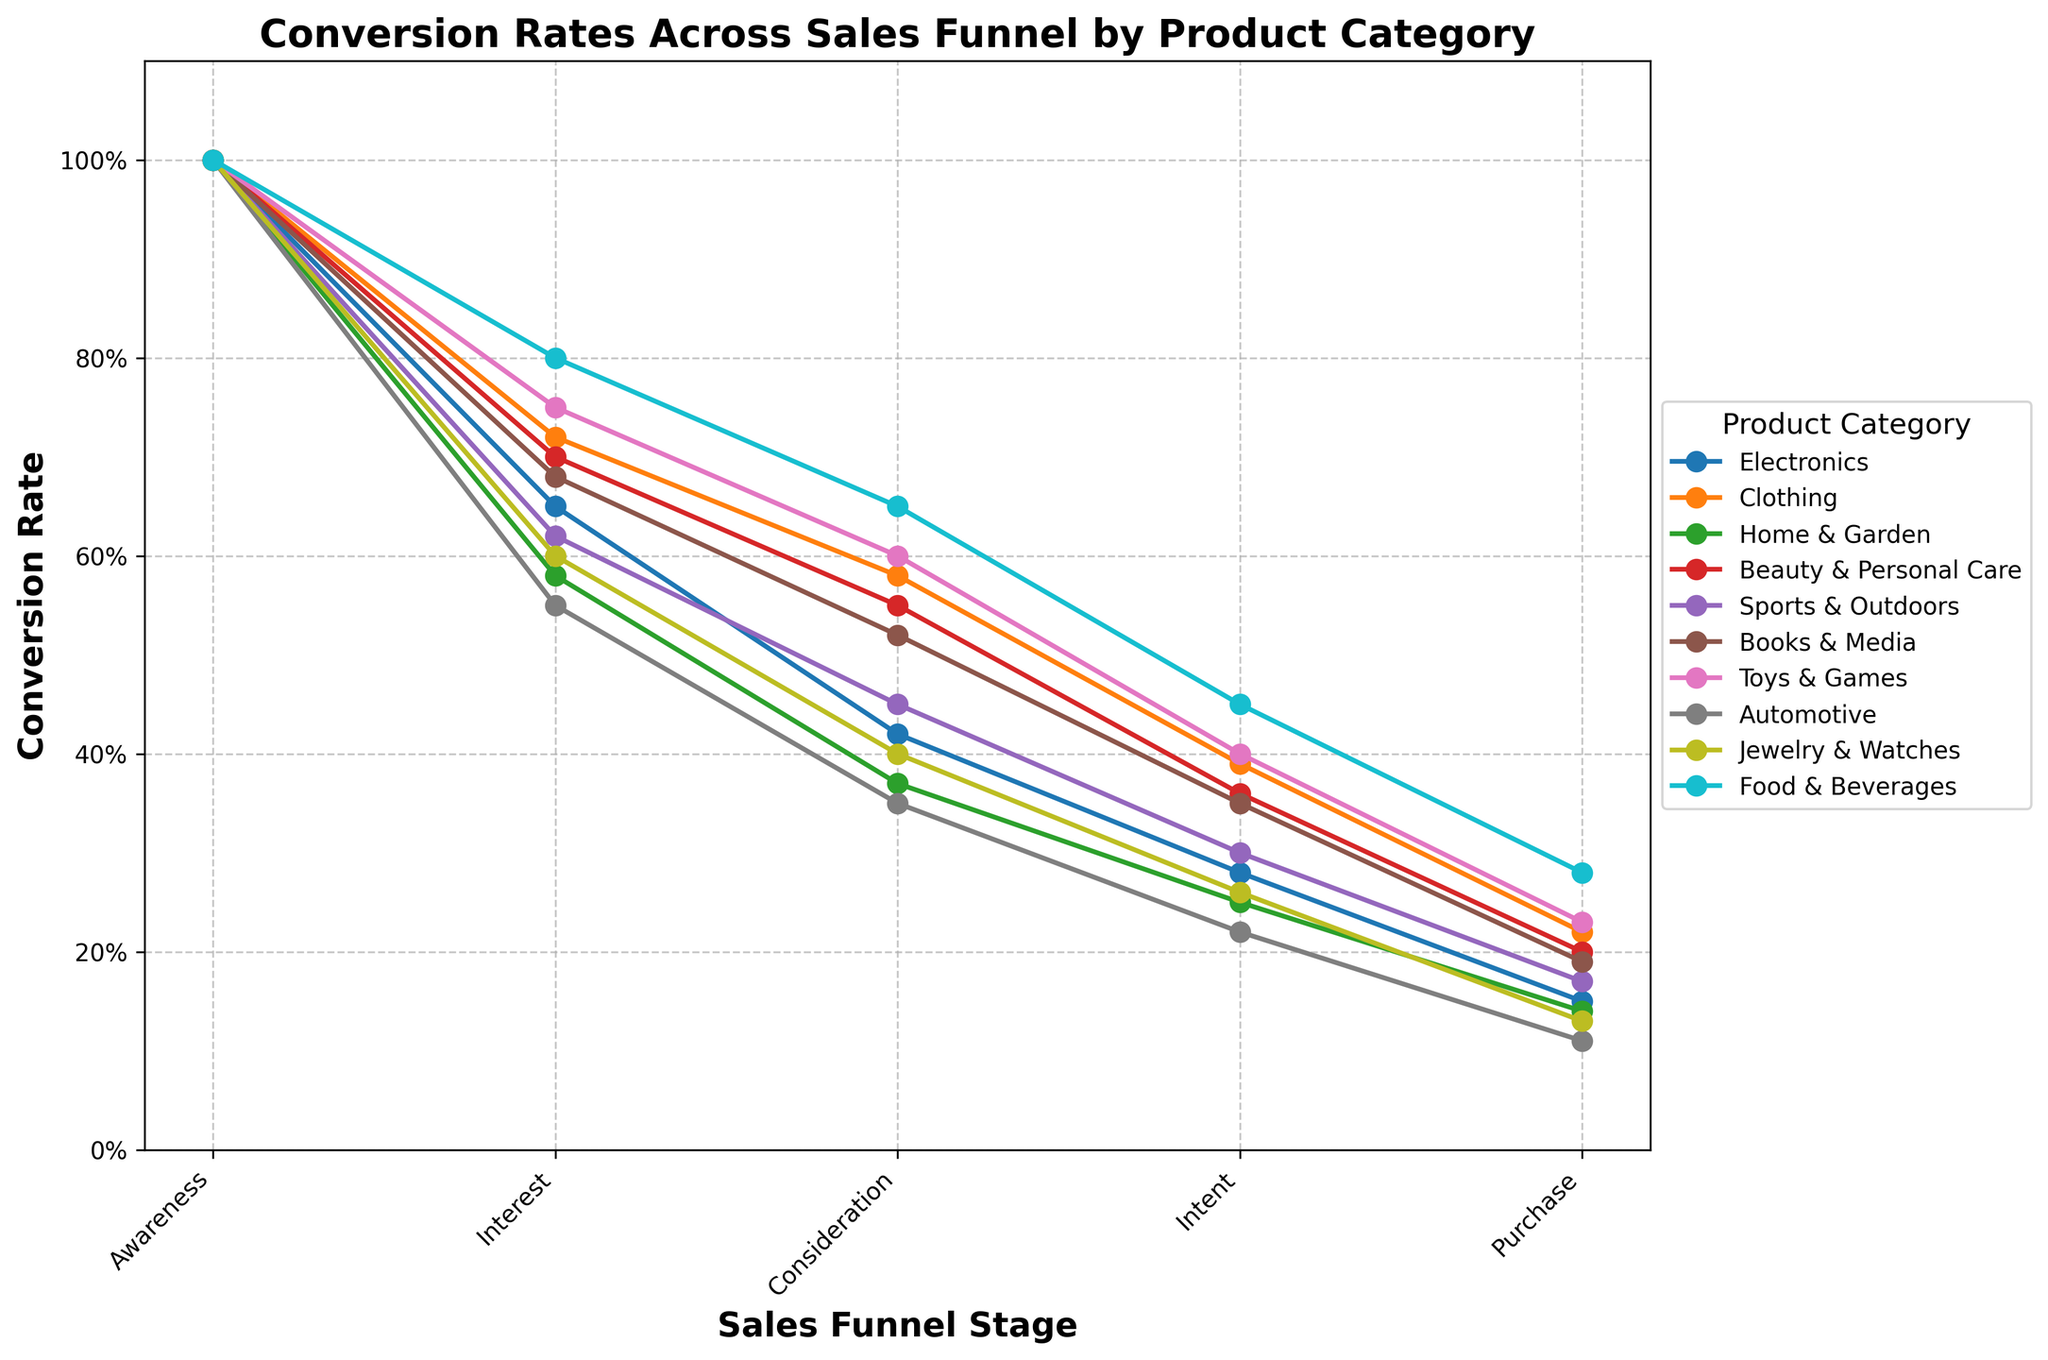What product category has the highest conversion rate at the "Interest" stage? To determine the product category with the highest conversion rate at the "Interest" stage, look at the values for all categories in this stage. The "Food & Beverages" category has an interest conversion rate of 80%, which is the highest among all categories.
Answer: Food & Beverages Which product category shows the steepest drop in conversion rate from "Consideration" to "Intent"? To find this, calculate the difference between the conversion rates of "Consideration" and "Intent" stages for each category. The "Automotive" category falls from 35% in "Consideration" to 22% in "Intent", a drop of 13%, which is the steepest among all categories.
Answer: Automotive Which two product categories have the closest conversion rates at the "Purchase" stage? Compare the conversion rates at the "Purchase" stage for all categories. "Home & Garden" and "Jewelry & Watches" both have close values of 14% and 13%, respectively, which are the closest pair.
Answer: Home & Garden and Jewelry & Watches What is the average conversion rate from "Awareness" to "Purchase" for the "Beauty & Personal Care" category? First, note the conversion rates for "Beauty & Personal Care" are 100%, 70%, 55%, 36%, and 20%. Convert these percentages and sum them: (1 + 0.70 + 0.55 + 0.36 + 0.20) = 2.81. Then, divide by the number of stages, 5, to get the average: 2.81 / 5 = 0.562 or 56.2%.
Answer: 56.2% Do any categories maintain a conversion rate above 50% at the "Consideration" stage? Examine "Consideration" stage values. "Clothing" (58%), "Beauty & Personal Care" (55%), "Books & Media" (52%), and "Toys & Games" (60%) all have conversion rates above 50% at this stage.
Answer: Yes Which product category's conversion rate from "Awareness" to "Intent" is closest to its "Awareness" rate? Calculate the change from "Awareness" to "Intent" for each category and find the one closest to 100% (Awareness). "Food & Beverages" drop from 100% to 45%, which is 55%. Comparatively, "Clothing" drops from 100% to 39%, which is 61%, significantly closer to initial 100%.
Answer: Clothing What is the difference in the "Interest" stage conversion rate between the highest and lowest categories? The highest "Interest" rate is "Food & Beverages" at 80%, and the lowest is "Automotive" at 55%. The difference is 80% - 55% = 25%.
Answer: 25% How does the "Books & Media" category's conversion rate at "Intent" compare to "Toys & Games"? The conversion rate at the "Intent" stage for "Books & Media" is 35%, and for "Toys & Games," it's 40%. Thus, "Toys & Games" is 5 percentage points higher than "Books & Media".
Answer: Toys & Games is higher Which stage shows the most significant drop in conversion rate for the "Electronics" category? Evaluate the drops between stages for "Electronics": Awareness to Interest (35%), Interest to Consideration (23%), Consideration to Intent (14%), Intent to Purchase (13%). The largest drop is from "Awareness" to "Interest" at 35%.
Answer: Awareness to Interest Which product categories show at least a 30% drop from "Awareness" to "Consideration"? Look for categories where the drop from Awareness (100%) to Consideration is at least 30%. "Automotive" (55% - 35% = 20%), "Home & Garden" (58% - 37% = 21%), and "Jewelry & Watches" (60% - 40% = 20%) show a significant drop, but only "Electronics" (42%) has a 30% drop.
Answer: Electronics 